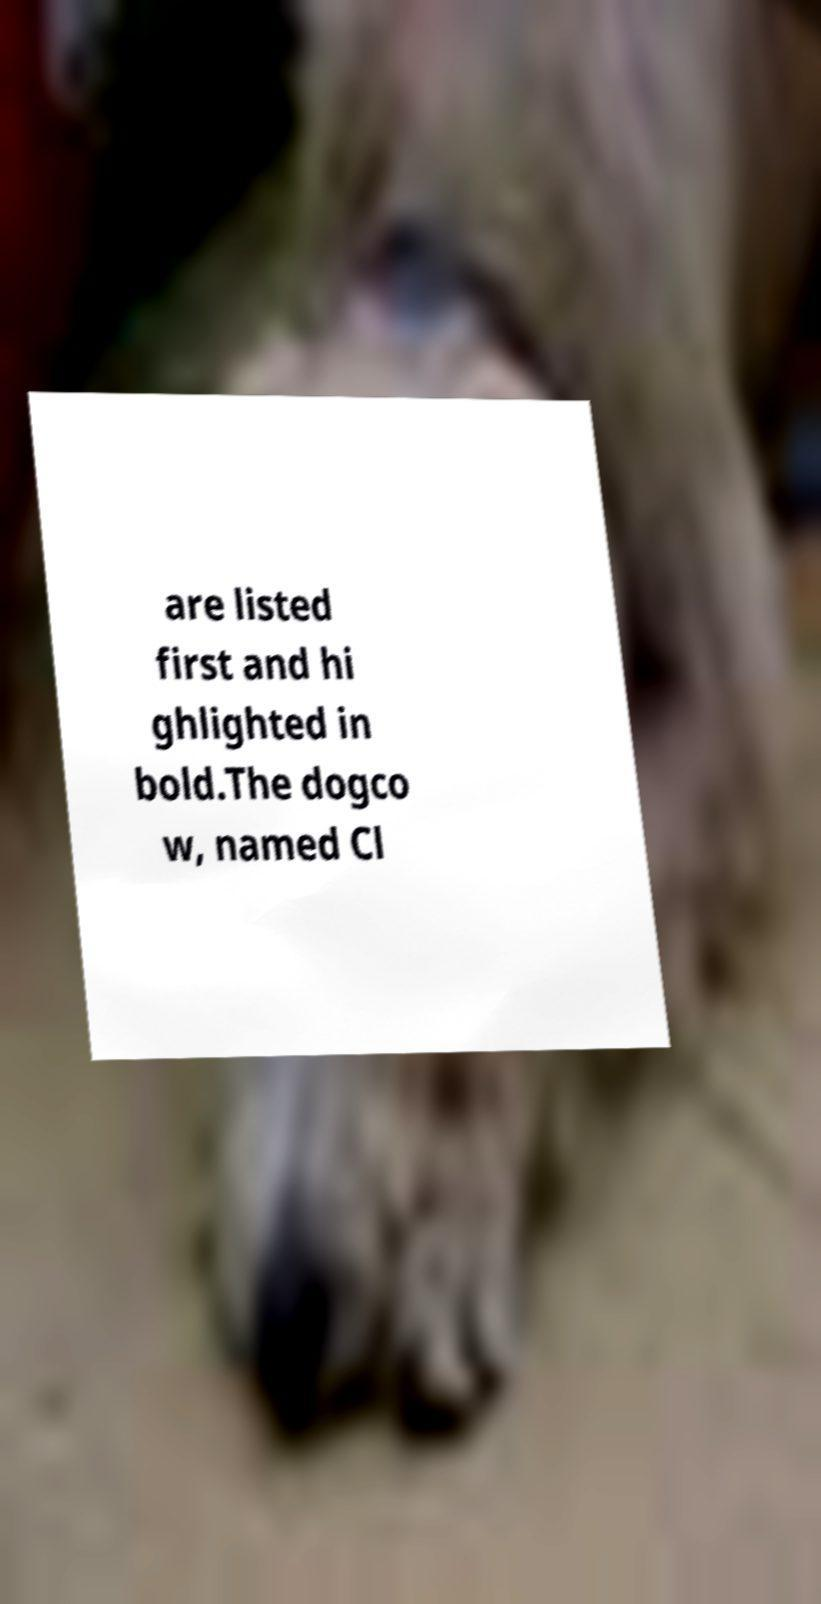Can you read and provide the text displayed in the image?This photo seems to have some interesting text. Can you extract and type it out for me? are listed first and hi ghlighted in bold.The dogco w, named Cl 